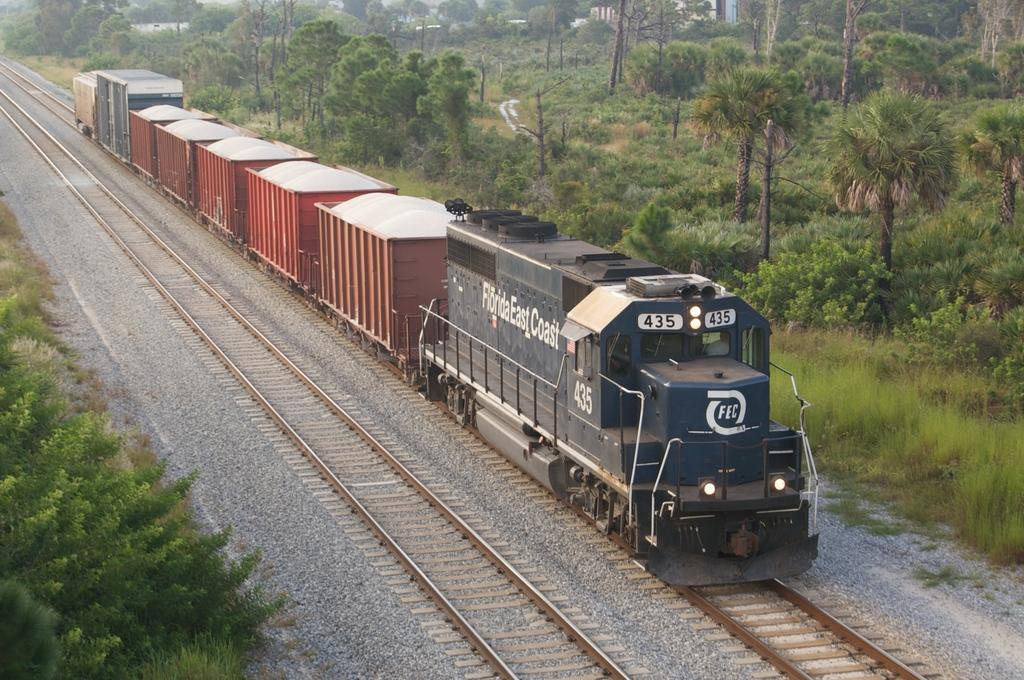What is the main subject of the image? There is a train in the image. What is the train traveling on? Railway tracks are present in the image. What type of natural elements can be seen in the image? Stones and plants are visible in the image. What is visible in the background of the image? There are trees in the background of the image. What type of wave can be seen crashing on the shore in the image? There is no wave or shore present in the image; it features a train, railway tracks, stones, plants, and trees. 